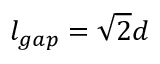<formula> <loc_0><loc_0><loc_500><loc_500>l _ { g a p } = \sqrt { 2 } d</formula> 